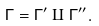Convert formula to latex. <formula><loc_0><loc_0><loc_500><loc_500>\Gamma = \Gamma ^ { \prime } \amalg \Gamma ^ { \prime \prime } .</formula> 